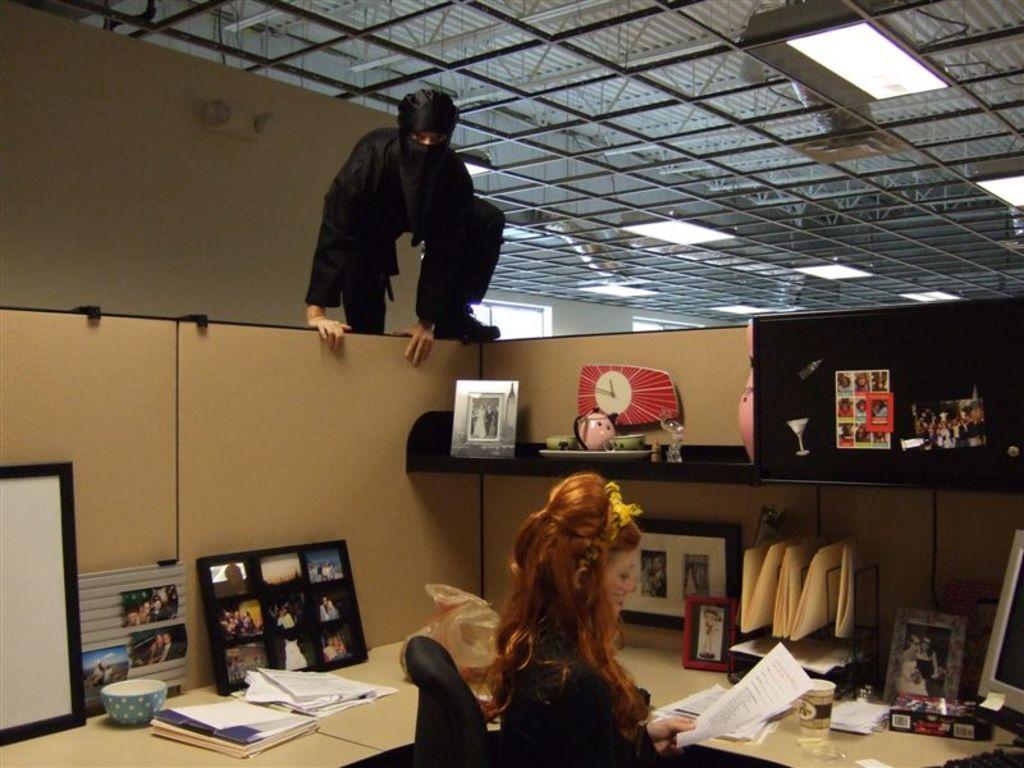Describe this image in one or two sentences. In this image I can see two people where one is sitting on a chair and here I can see a person is climbing. On these tables I can see few papers, frames , a clock, monitor and few more stuffs. 